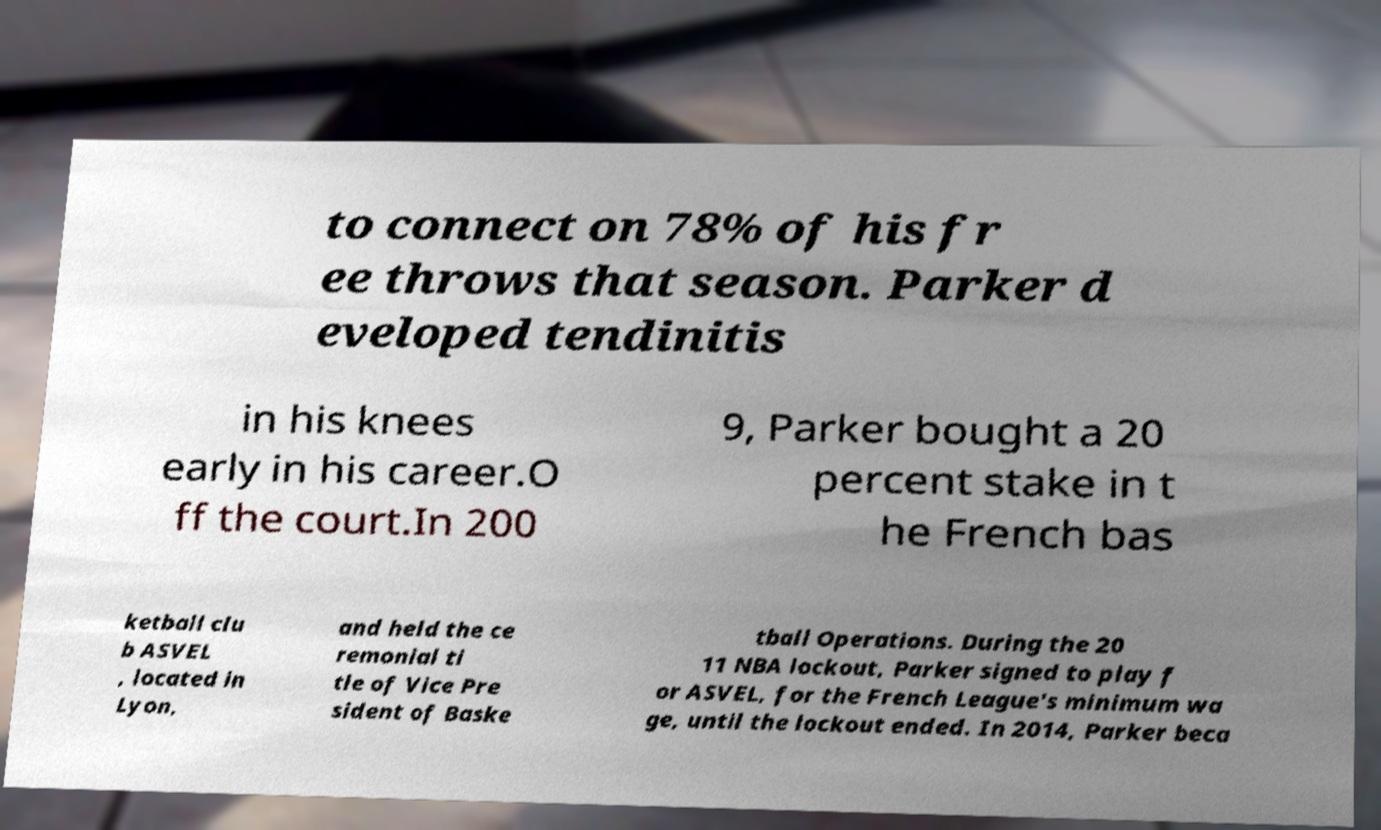For documentation purposes, I need the text within this image transcribed. Could you provide that? to connect on 78% of his fr ee throws that season. Parker d eveloped tendinitis in his knees early in his career.O ff the court.In 200 9, Parker bought a 20 percent stake in t he French bas ketball clu b ASVEL , located in Lyon, and held the ce remonial ti tle of Vice Pre sident of Baske tball Operations. During the 20 11 NBA lockout, Parker signed to play f or ASVEL, for the French League's minimum wa ge, until the lockout ended. In 2014, Parker beca 